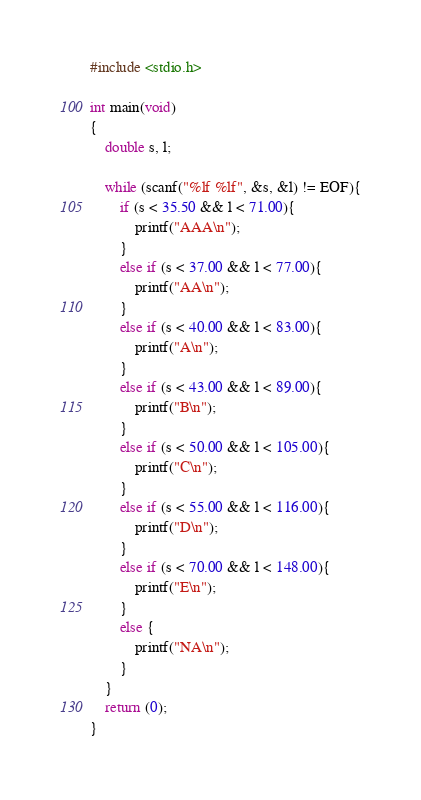<code> <loc_0><loc_0><loc_500><loc_500><_C_>#include <stdio.h>

int main(void)
{
	double s, l;
	
	while (scanf("%lf %lf", &s, &l) != EOF){
		if (s < 35.50 && l < 71.00){
			printf("AAA\n");
		}
		else if (s < 37.00 && l < 77.00){
			printf("AA\n");
		}
		else if (s < 40.00 && l < 83.00){
			printf("A\n");
		}
		else if (s < 43.00 && l < 89.00){
			printf("B\n");
		}
		else if (s < 50.00 && l < 105.00){
			printf("C\n");
		}
		else if (s < 55.00 && l < 116.00){
			printf("D\n");
		}
		else if (s < 70.00 && l < 148.00){
			printf("E\n");
		}
		else {
			printf("NA\n");
		}
	}
	return (0);
}</code> 